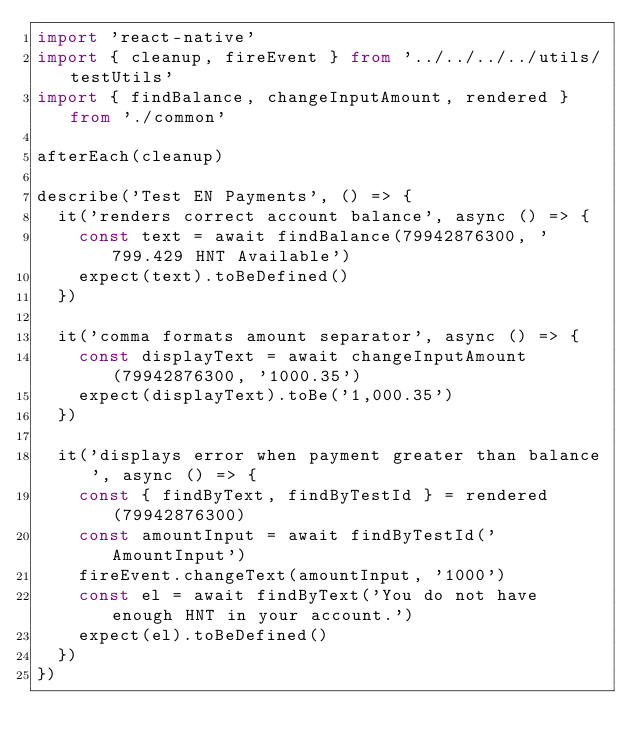Convert code to text. <code><loc_0><loc_0><loc_500><loc_500><_TypeScript_>import 'react-native'
import { cleanup, fireEvent } from '../../../../utils/testUtils'
import { findBalance, changeInputAmount, rendered } from './common'

afterEach(cleanup)

describe('Test EN Payments', () => {
  it('renders correct account balance', async () => {
    const text = await findBalance(79942876300, '799.429 HNT Available')
    expect(text).toBeDefined()
  })

  it('comma formats amount separator', async () => {
    const displayText = await changeInputAmount(79942876300, '1000.35')
    expect(displayText).toBe('1,000.35')
  })

  it('displays error when payment greater than balance', async () => {
    const { findByText, findByTestId } = rendered(79942876300)
    const amountInput = await findByTestId('AmountInput')
    fireEvent.changeText(amountInput, '1000')
    const el = await findByText('You do not have enough HNT in your account.')
    expect(el).toBeDefined()
  })
})
</code> 